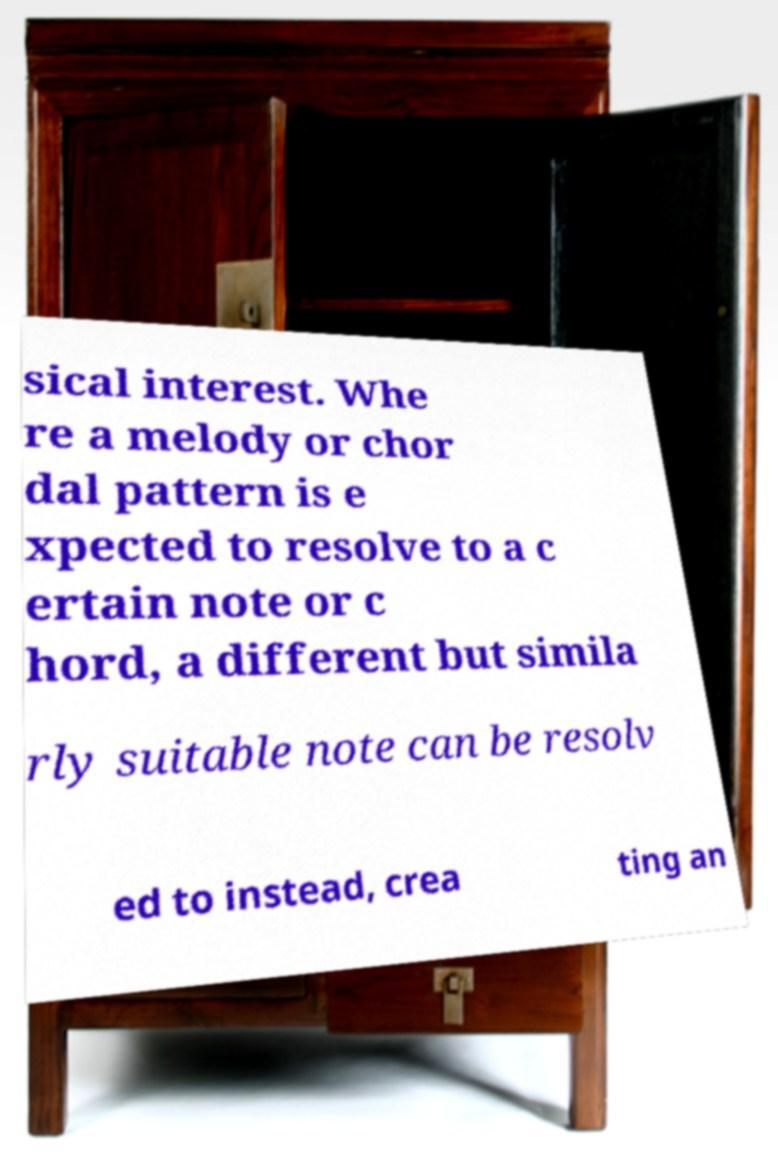I need the written content from this picture converted into text. Can you do that? sical interest. Whe re a melody or chor dal pattern is e xpected to resolve to a c ertain note or c hord, a different but simila rly suitable note can be resolv ed to instead, crea ting an 